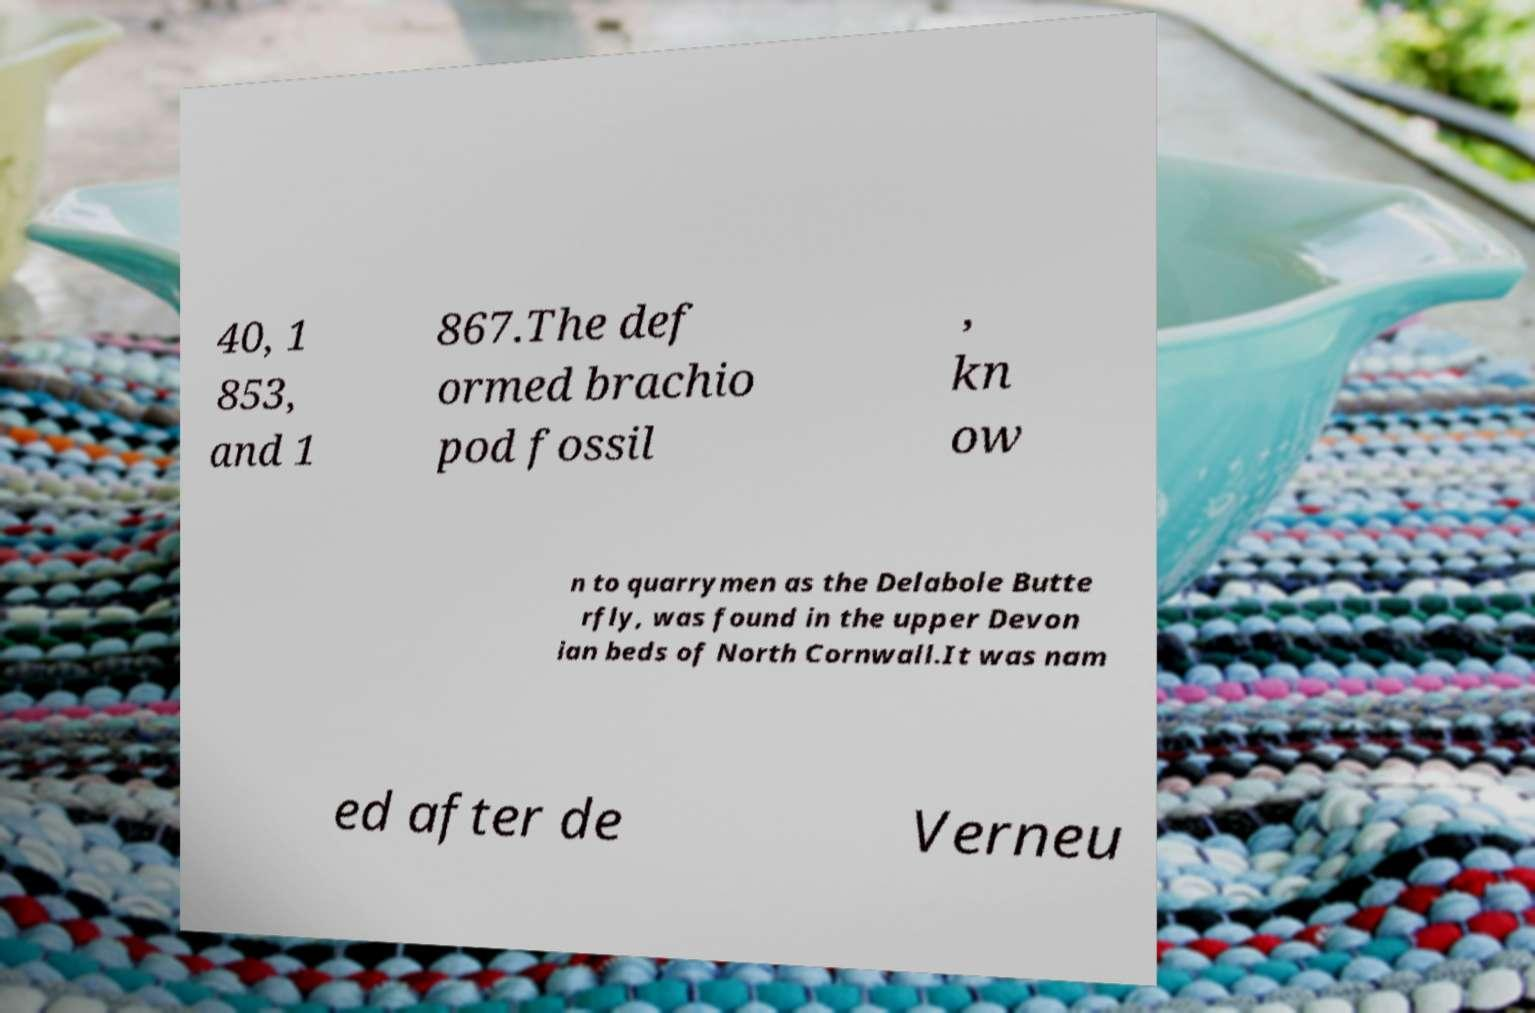Please identify and transcribe the text found in this image. 40, 1 853, and 1 867.The def ormed brachio pod fossil , kn ow n to quarrymen as the Delabole Butte rfly, was found in the upper Devon ian beds of North Cornwall.It was nam ed after de Verneu 